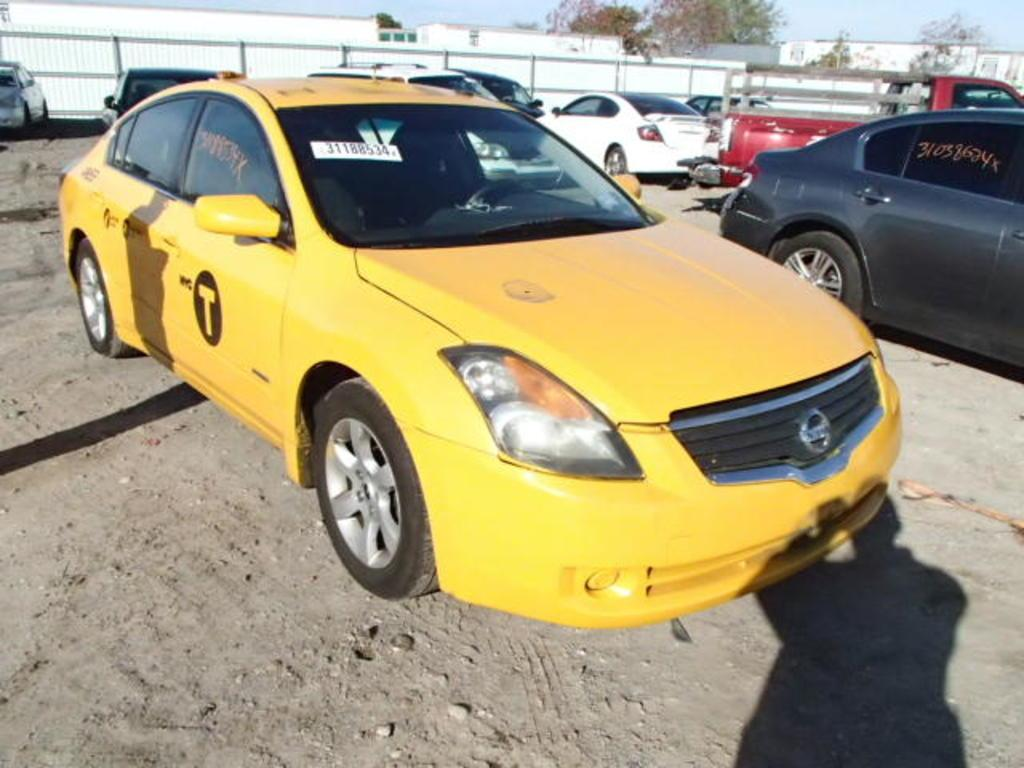<image>
Share a concise interpretation of the image provided. The letter T can be seen on the side door of this yellow car. 